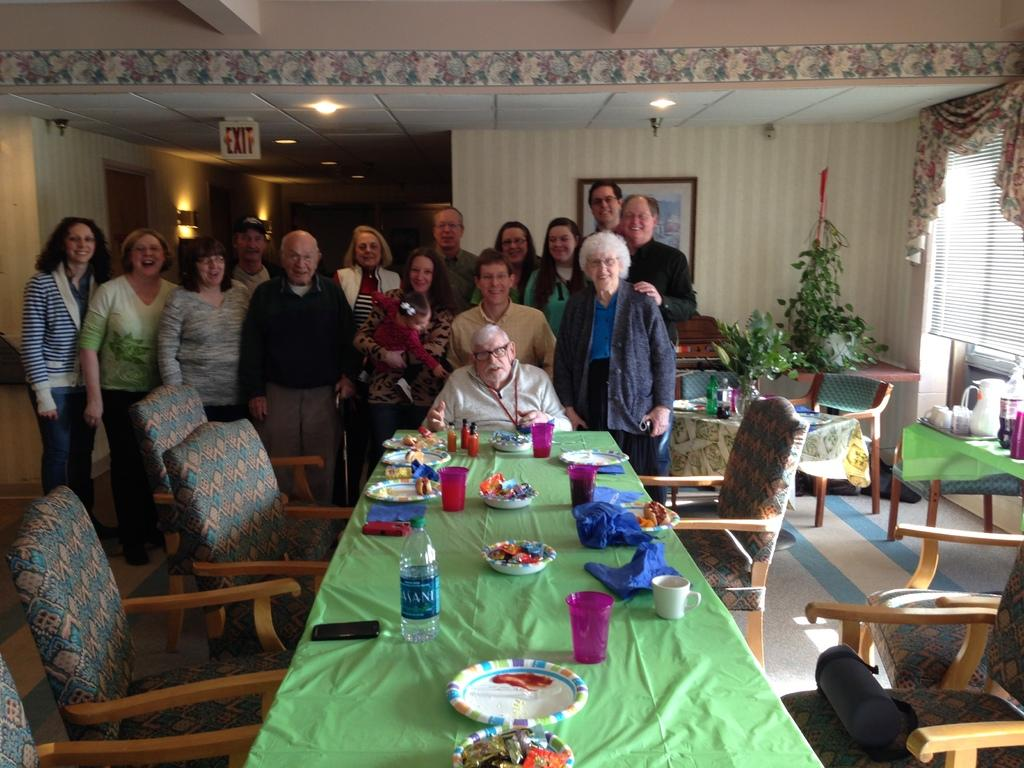Who is present in the image? There are old men in the picture. Where are the old men located in the image? The old men are at the back side of the image. What can be seen on the dining table in the image? There are plates and food on the dining table. What type of room is depicted in the image? The setting appears to be in a dining room. What type of bread is the queen eating in the image? There is no queen or bread present in the image; it features old men in a dining room. How does the brain of the old man on the left side of the image function? There is no information about the old men's brains in the image, and therefore we cannot determine how they function. 